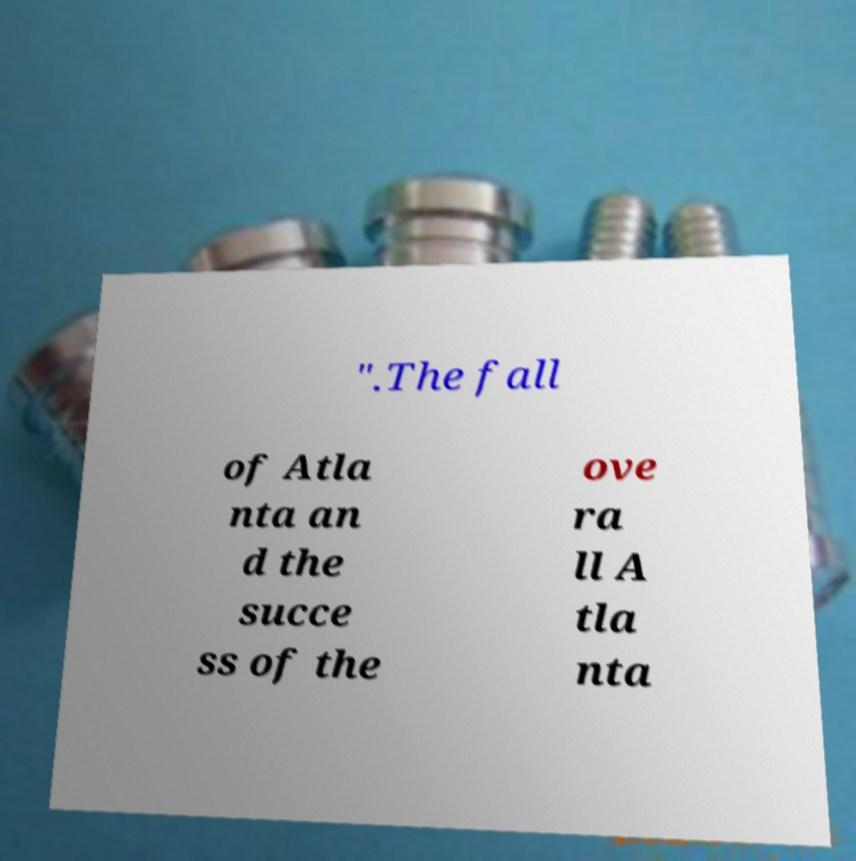I need the written content from this picture converted into text. Can you do that? ".The fall of Atla nta an d the succe ss of the ove ra ll A tla nta 